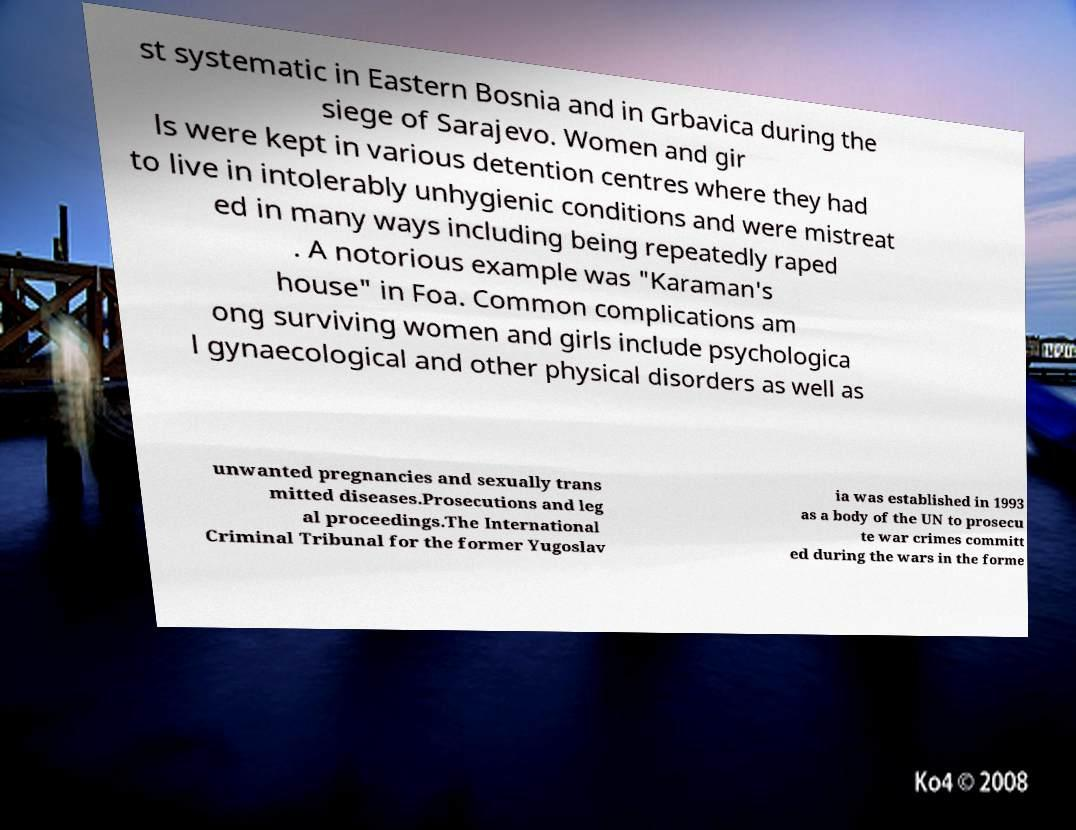Could you extract and type out the text from this image? st systematic in Eastern Bosnia and in Grbavica during the siege of Sarajevo. Women and gir ls were kept in various detention centres where they had to live in intolerably unhygienic conditions and were mistreat ed in many ways including being repeatedly raped . A notorious example was "Karaman's house" in Foa. Common complications am ong surviving women and girls include psychologica l gynaecological and other physical disorders as well as unwanted pregnancies and sexually trans mitted diseases.Prosecutions and leg al proceedings.The International Criminal Tribunal for the former Yugoslav ia was established in 1993 as a body of the UN to prosecu te war crimes committ ed during the wars in the forme 